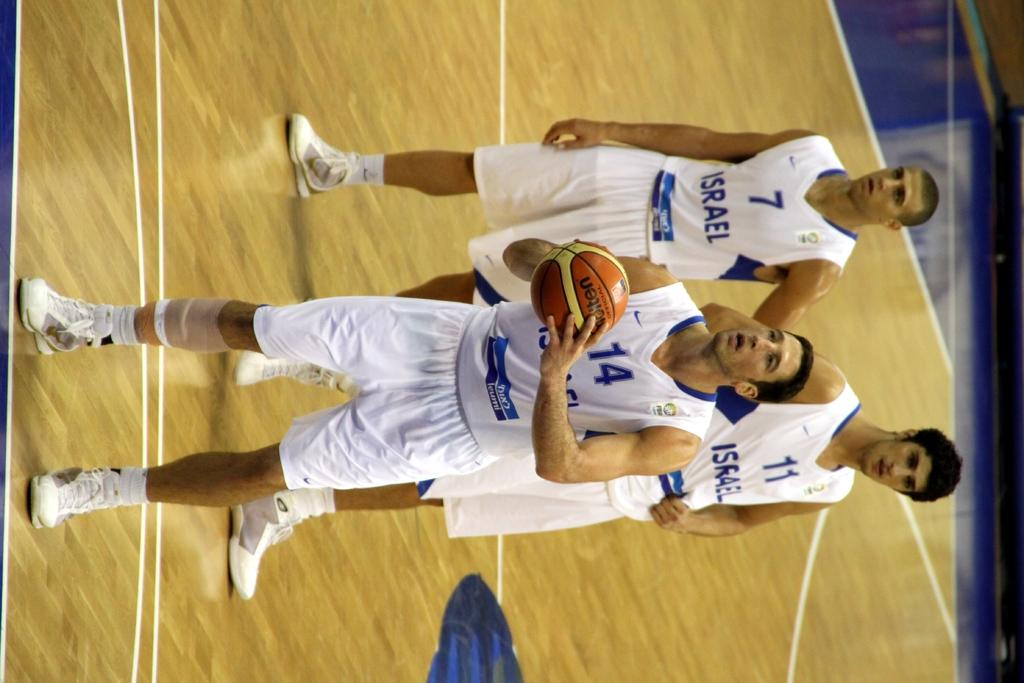<image>
Present a compact description of the photo's key features. A basketball player for Israel gets in a stance to shoot a free throw while two of his teammates watch. 